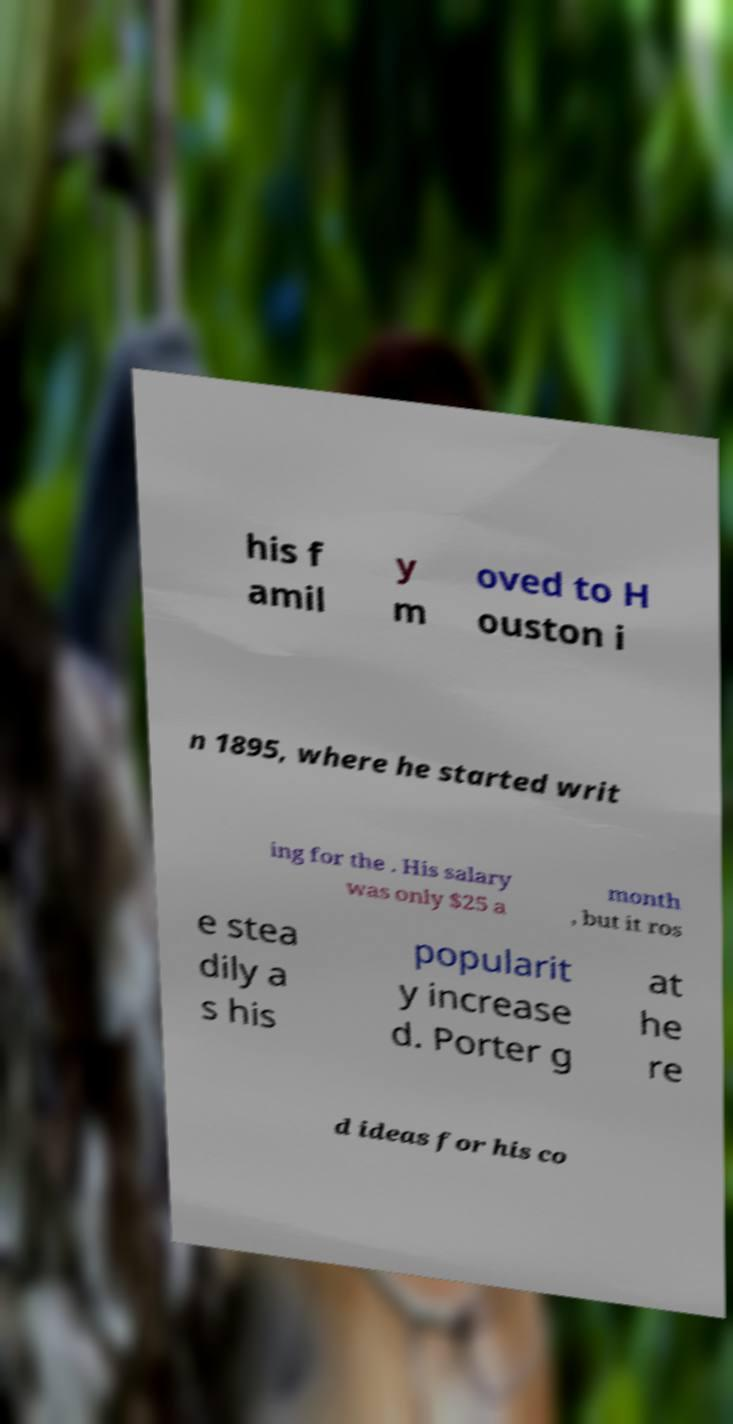There's text embedded in this image that I need extracted. Can you transcribe it verbatim? his f amil y m oved to H ouston i n 1895, where he started writ ing for the . His salary was only $25 a month , but it ros e stea dily a s his popularit y increase d. Porter g at he re d ideas for his co 